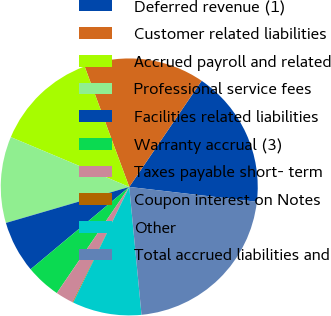Convert chart. <chart><loc_0><loc_0><loc_500><loc_500><pie_chart><fcel>Deferred revenue (1)<fcel>Customer related liabilities<fcel>Accrued payroll and related<fcel>Professional service fees<fcel>Facilities related liabilities<fcel>Warranty accrual (3)<fcel>Taxes payable short- term<fcel>Coupon interest on Notes<fcel>Other<fcel>Total accrued liabilities and<nl><fcel>17.32%<fcel>15.17%<fcel>13.02%<fcel>10.86%<fcel>6.55%<fcel>4.4%<fcel>2.25%<fcel>0.09%<fcel>8.71%<fcel>21.63%<nl></chart> 